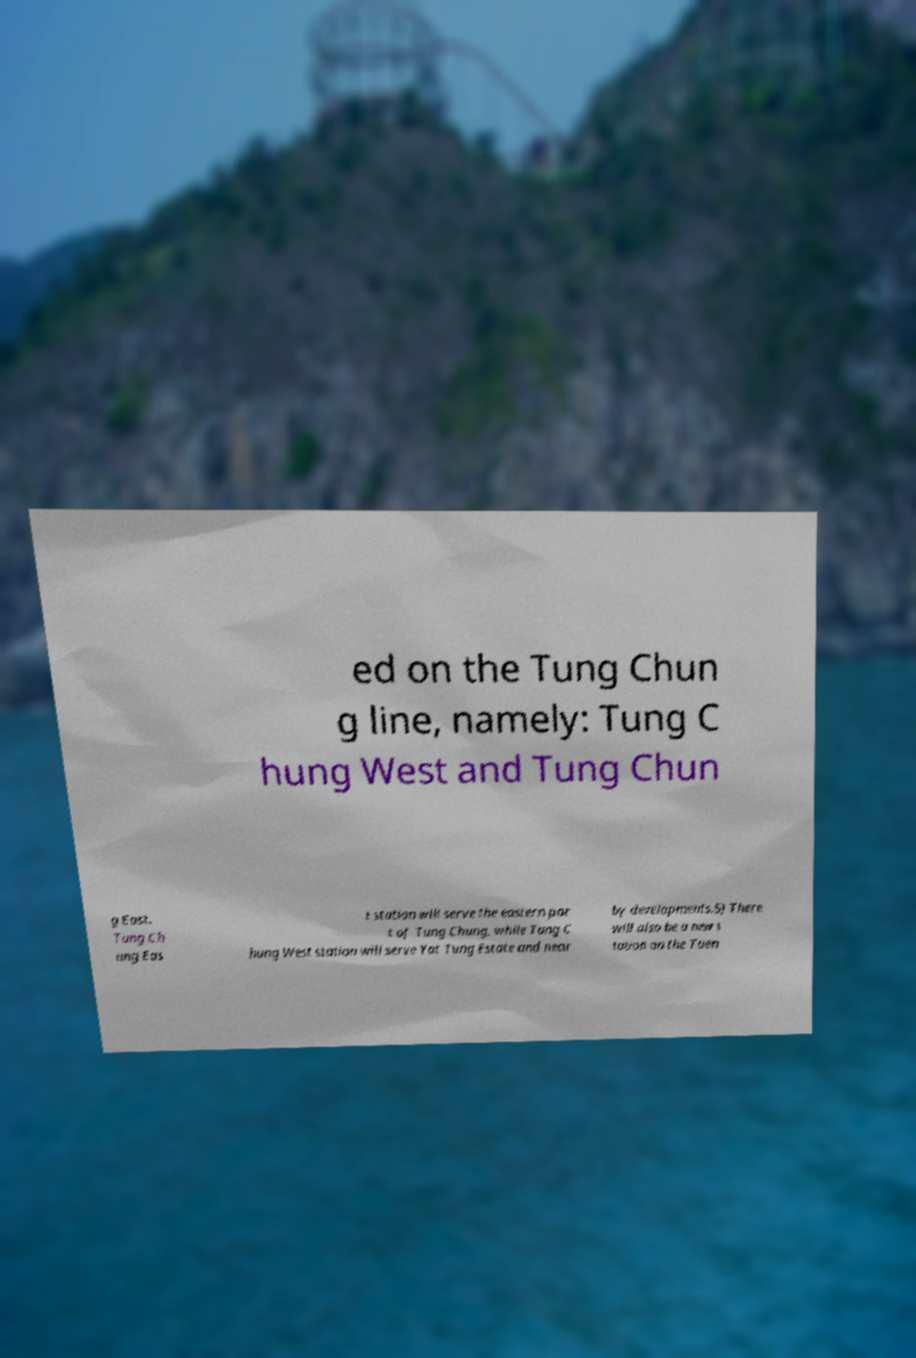Can you read and provide the text displayed in the image?This photo seems to have some interesting text. Can you extract and type it out for me? ed on the Tung Chun g line, namely: Tung C hung West and Tung Chun g East. Tung Ch ung Eas t station will serve the eastern par t of Tung Chung, while Tung C hung West station will serve Yat Tung Estate and near by developments.5) There will also be a new s tation on the Tuen 